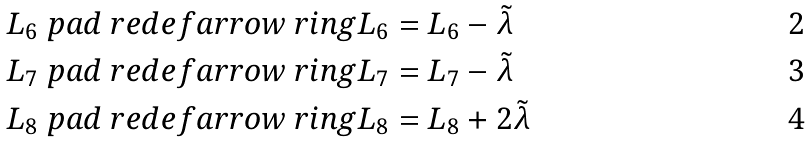<formula> <loc_0><loc_0><loc_500><loc_500>L _ { 6 } & \ p a d { \ r e d e f a r r o w } \ r i n g { L } _ { 6 } = L _ { 6 } - \tilde { \lambda } \\ L _ { 7 } & \ p a d { \ r e d e f a r r o w } \ r i n g { L } _ { 7 } = L _ { 7 } - \tilde { \lambda } \\ L _ { 8 } & \ p a d { \ r e d e f a r r o w } \ r i n g { L } _ { 8 } = L _ { 8 } + 2 \tilde { \lambda }</formula> 